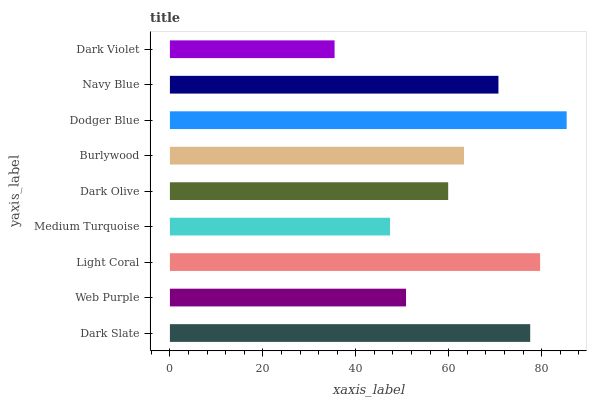Is Dark Violet the minimum?
Answer yes or no. Yes. Is Dodger Blue the maximum?
Answer yes or no. Yes. Is Web Purple the minimum?
Answer yes or no. No. Is Web Purple the maximum?
Answer yes or no. No. Is Dark Slate greater than Web Purple?
Answer yes or no. Yes. Is Web Purple less than Dark Slate?
Answer yes or no. Yes. Is Web Purple greater than Dark Slate?
Answer yes or no. No. Is Dark Slate less than Web Purple?
Answer yes or no. No. Is Burlywood the high median?
Answer yes or no. Yes. Is Burlywood the low median?
Answer yes or no. Yes. Is Dark Slate the high median?
Answer yes or no. No. Is Dark Olive the low median?
Answer yes or no. No. 